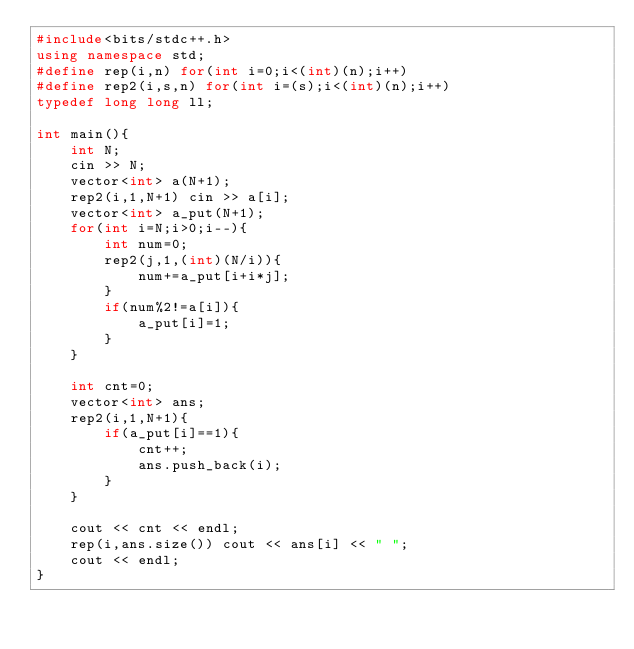<code> <loc_0><loc_0><loc_500><loc_500><_C++_>#include<bits/stdc++.h>
using namespace std;
#define rep(i,n) for(int i=0;i<(int)(n);i++)
#define rep2(i,s,n) for(int i=(s);i<(int)(n);i++)
typedef long long ll;

int main(){
    int N;
    cin >> N;
    vector<int> a(N+1);
    rep2(i,1,N+1) cin >> a[i];
    vector<int> a_put(N+1);
    for(int i=N;i>0;i--){
        int num=0;
        rep2(j,1,(int)(N/i)){
            num+=a_put[i+i*j];
        }
        if(num%2!=a[i]){
            a_put[i]=1;
        }
    }

    int cnt=0;
    vector<int> ans;
    rep2(i,1,N+1){
        if(a_put[i]==1){
            cnt++;
            ans.push_back(i);
        }
    }

    cout << cnt << endl;
    rep(i,ans.size()) cout << ans[i] << " ";
    cout << endl;
}</code> 